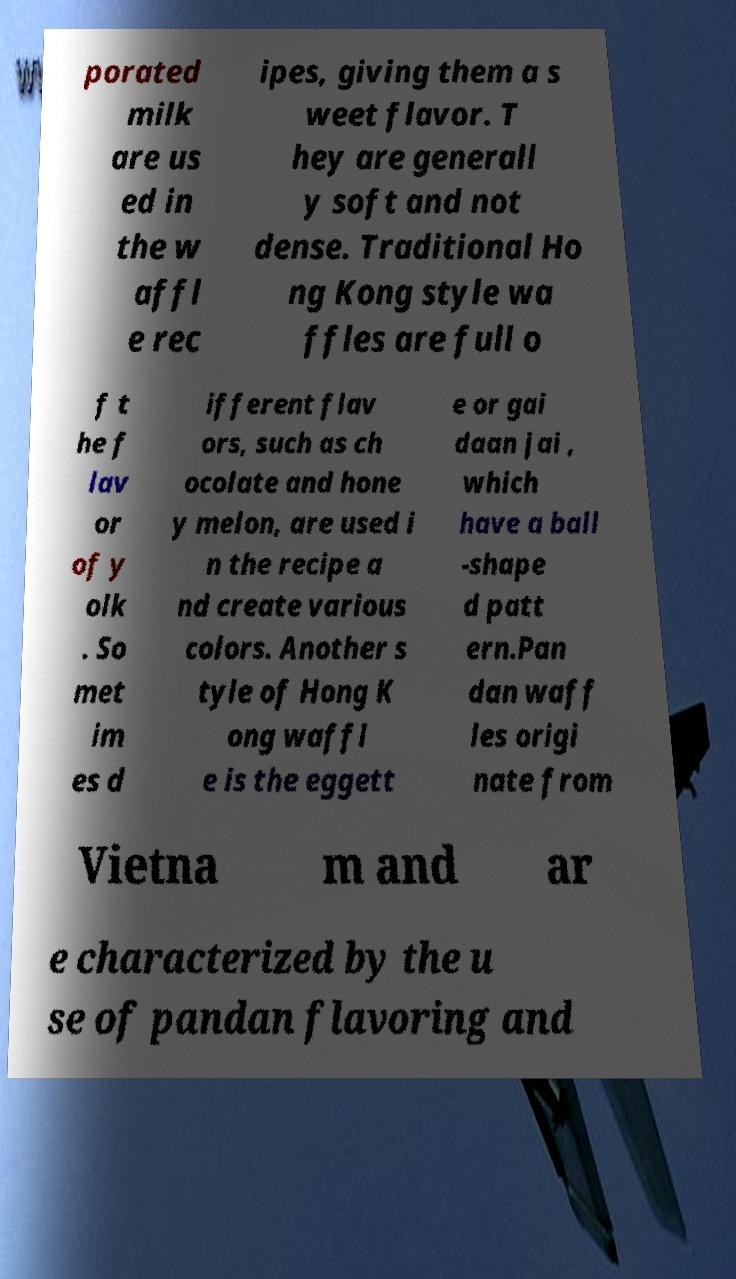Can you accurately transcribe the text from the provided image for me? porated milk are us ed in the w affl e rec ipes, giving them a s weet flavor. T hey are generall y soft and not dense. Traditional Ho ng Kong style wa ffles are full o f t he f lav or of y olk . So met im es d ifferent flav ors, such as ch ocolate and hone y melon, are used i n the recipe a nd create various colors. Another s tyle of Hong K ong waffl e is the eggett e or gai daan jai , which have a ball -shape d patt ern.Pan dan waff les origi nate from Vietna m and ar e characterized by the u se of pandan flavoring and 